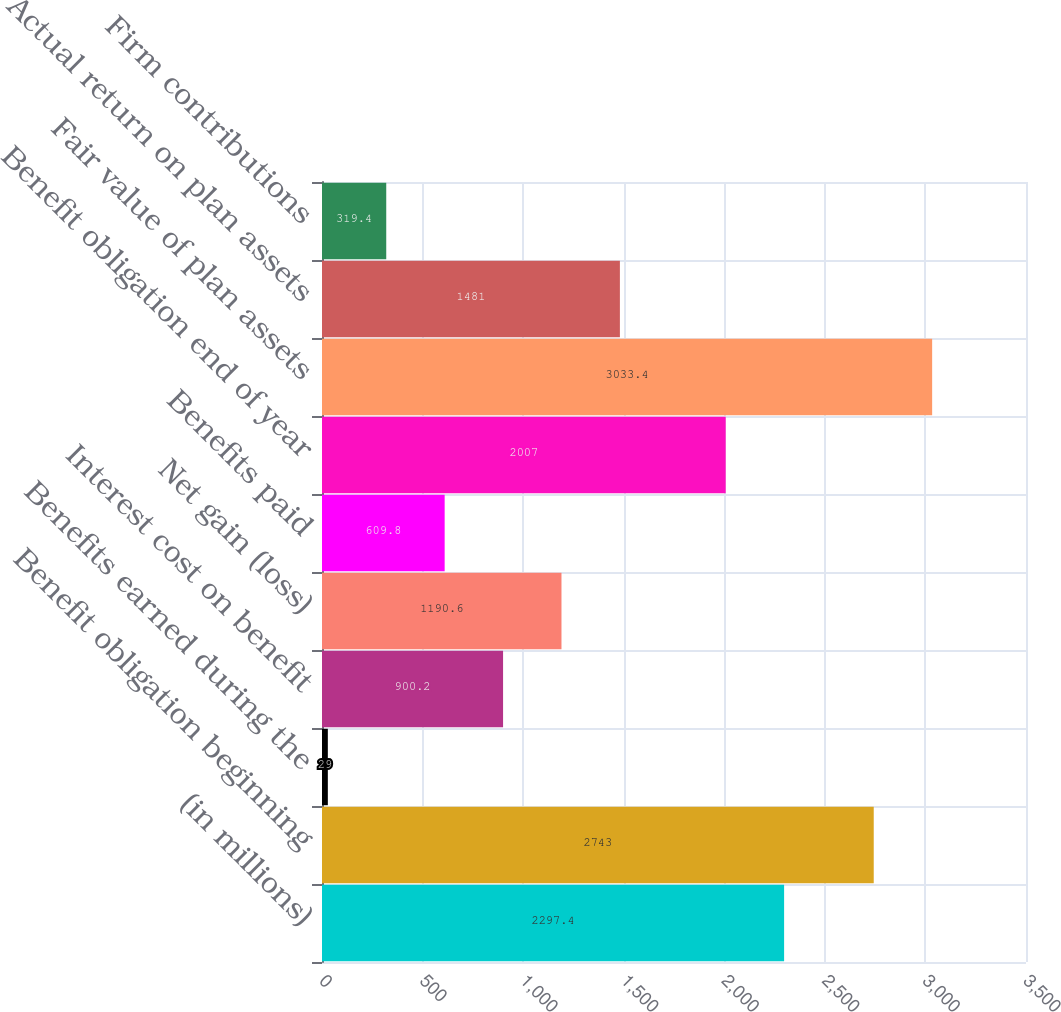Convert chart. <chart><loc_0><loc_0><loc_500><loc_500><bar_chart><fcel>(in millions)<fcel>Benefit obligation beginning<fcel>Benefits earned during the<fcel>Interest cost on benefit<fcel>Net gain (loss)<fcel>Benefits paid<fcel>Benefit obligation end of year<fcel>Fair value of plan assets<fcel>Actual return on plan assets<fcel>Firm contributions<nl><fcel>2297.4<fcel>2743<fcel>29<fcel>900.2<fcel>1190.6<fcel>609.8<fcel>2007<fcel>3033.4<fcel>1481<fcel>319.4<nl></chart> 